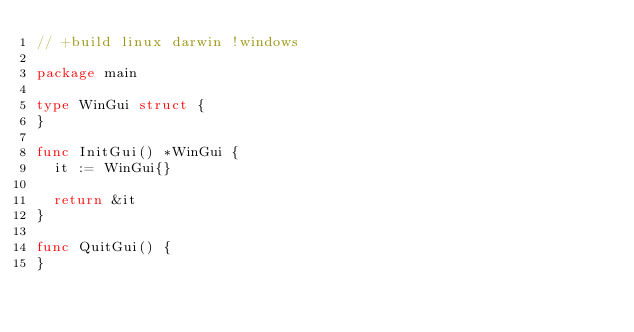<code> <loc_0><loc_0><loc_500><loc_500><_Go_>// +build linux darwin !windows

package main

type WinGui struct {
}

func InitGui() *WinGui {
	it := WinGui{}

	return &it
}

func QuitGui() {
}
</code> 